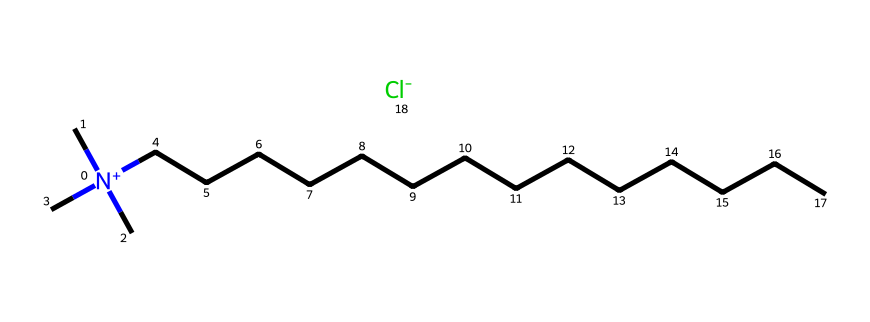What is the central atom of this compound? The central atom in quaternary ammonium compounds is nitrogen. In this SMILES representation, it is indicated by [N+], which is a positively charged nitrogen atom situated in the middle with three methyl (C) groups and a long carbon chain attached.
Answer: nitrogen How many carbon atoms are in the longest chain? The longest carbon chain in this compound can be seen connected to the nitrogen atom. By counting the "C" characters in the longest sequence following the nitrogen, there are 14 carbon atoms before reaching the end of the chain.
Answer: 14 What type of ion is associated with this compound? The compound includes [Cl-], which indicates a chloride ion. In quaternary ammonium compounds, the positive charge on nitrogen (indicated by [N+]) is balanced by the negatively charged chloride ion.
Answer: chloride What charge does the nitrogen atom carry in this compound? The nitrogen atom in this compound is indicated as [N+], signifying a positive charge. This is a defining characteristic of quaternary ammonium compounds, where the nitrogen is positively charged and bonded to various alkyl groups.
Answer: positive What role do quaternary ammonium compounds play in disinfectant wipes? Quaternary ammonium compounds act as disinfectants due to their surfactant properties, effectively breaking down cell membranes of bacteria and viruses, thereby leading to their inactivation.
Answer: disinfectant What physical state is this compound likely to be in at room temperature? Given that it is a quaternary ammonium compound with a long carbon chain, it is typically a solid at room temperature due to the extensive hydrophobic interactions of the long carbon tail.
Answer: solid 